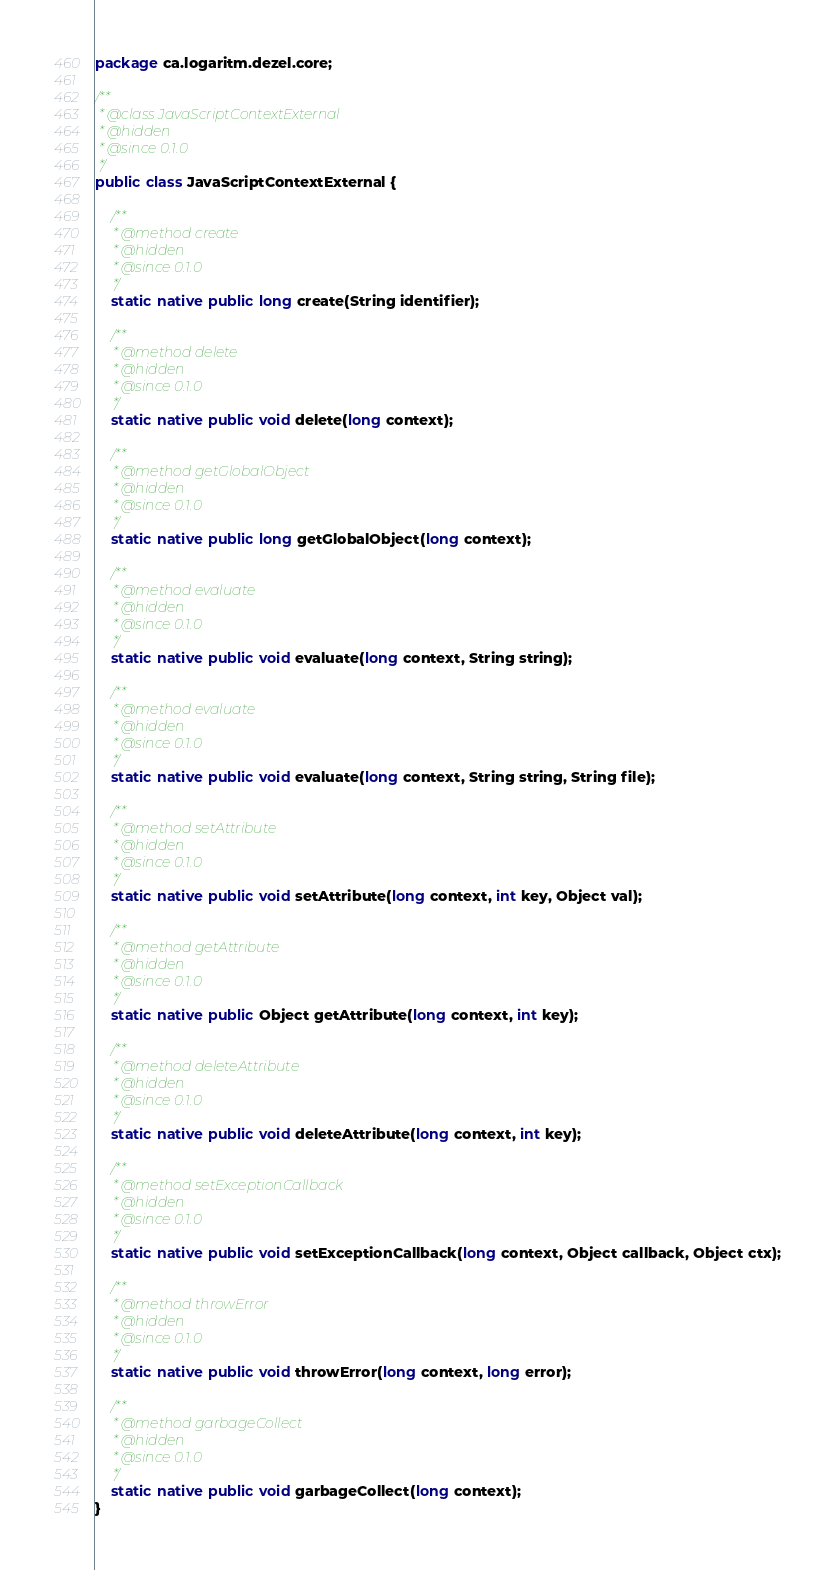Convert code to text. <code><loc_0><loc_0><loc_500><loc_500><_Java_>package ca.logaritm.dezel.core;

/**
 * @class JavaScriptContextExternal
 * @hidden
 * @since 0.1.0
 */
public class JavaScriptContextExternal {

	/**
	 * @method create
	 * @hidden
	 * @since 0.1.0
	 */
	static native public long create(String identifier);

	/**
	 * @method delete
	 * @hidden
	 * @since 0.1.0
	 */
	static native public void delete(long context);

	/**
	 * @method getGlobalObject
	 * @hidden
	 * @since 0.1.0
	 */
	static native public long getGlobalObject(long context);

	/**
	 * @method evaluate
	 * @hidden
	 * @since 0.1.0
	 */
	static native public void evaluate(long context, String string);

	/**
	 * @method evaluate
	 * @hidden
	 * @since 0.1.0
	 */
	static native public void evaluate(long context, String string, String file);

	/**
	 * @method setAttribute
	 * @hidden
	 * @since 0.1.0
	 */
	static native public void setAttribute(long context, int key, Object val);

	/**
	 * @method getAttribute
	 * @hidden
	 * @since 0.1.0
	 */
	static native public Object getAttribute(long context, int key);

	/**
	 * @method deleteAttribute
	 * @hidden
	 * @since 0.1.0
	 */
	static native public void deleteAttribute(long context, int key);

	/**
	 * @method setExceptionCallback
	 * @hidden
	 * @since 0.1.0
	 */
	static native public void setExceptionCallback(long context, Object callback, Object ctx);

	/**
	 * @method throwError
	 * @hidden
	 * @since 0.1.0
	 */
	static native public void throwError(long context, long error);

	/**
	 * @method garbageCollect
	 * @hidden
	 * @since 0.1.0
	 */
	static native public void garbageCollect(long context);
}
</code> 